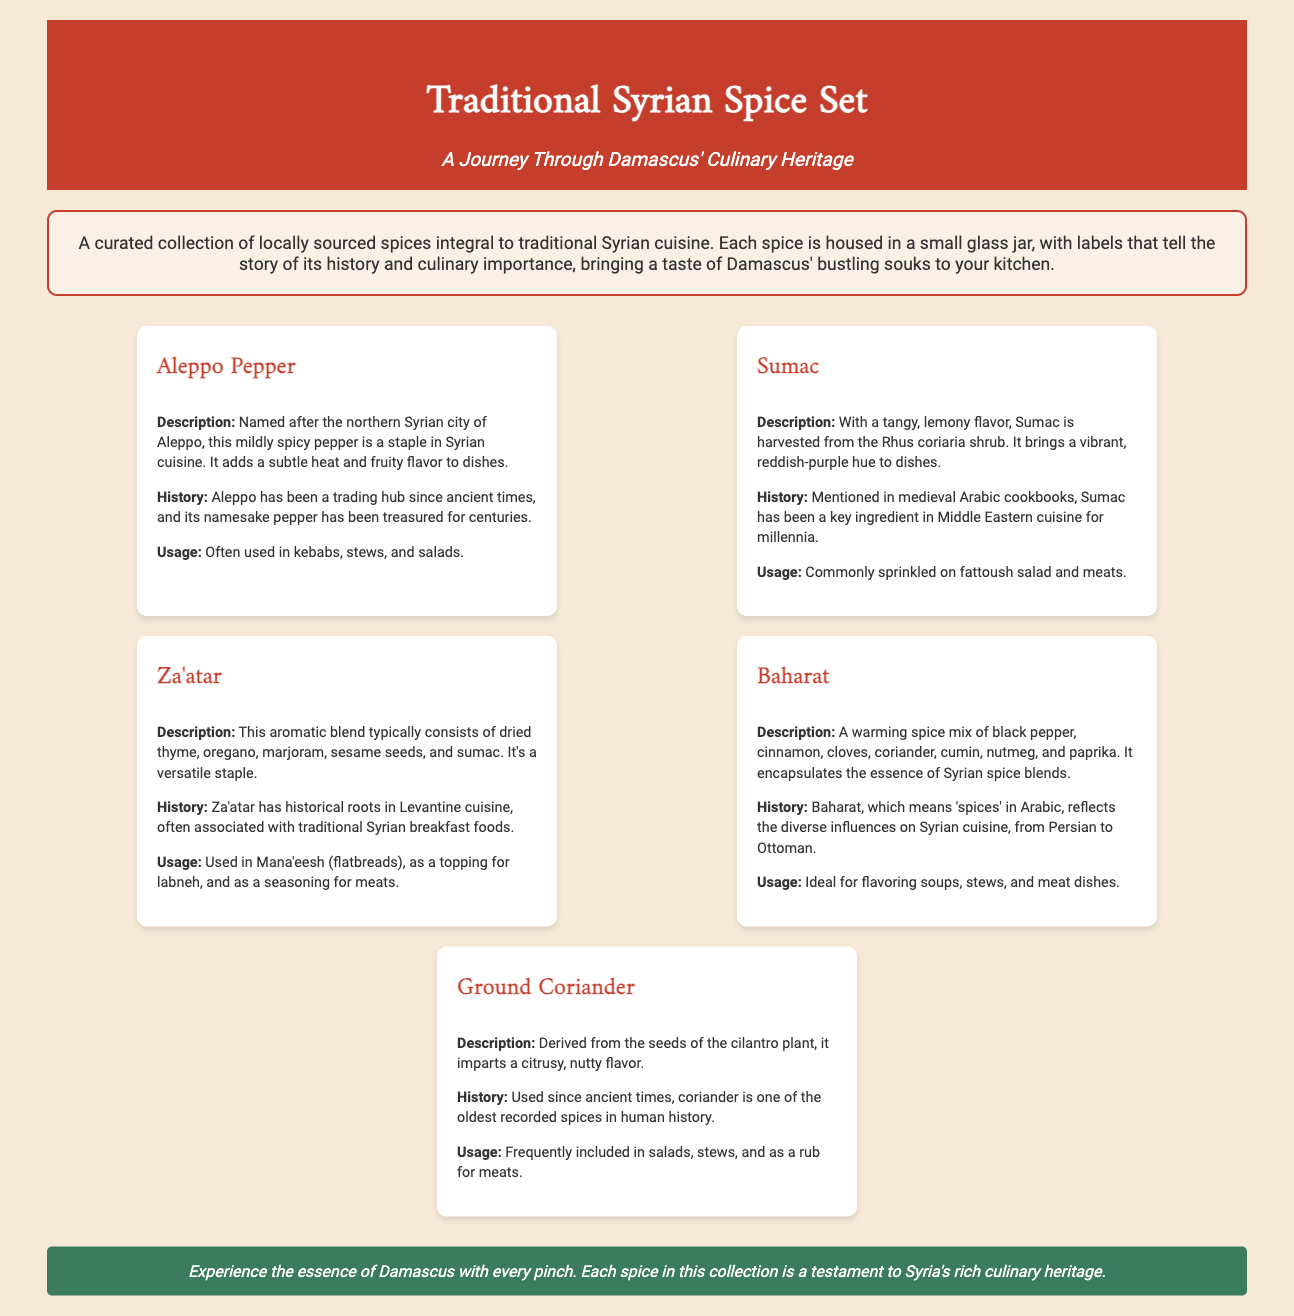What is the title of the product? The title of the product is prominently displayed at the top of the document.
Answer: Traditional Syrian Spice Set How many spices are included in the set? The document lists five different spices, each in its own section.
Answer: Five What spice is made from dried thyme and sesame seeds? The description outlines the components of this spice blend.
Answer: Za'atar Which spice is described as having a tangy, lemony flavor? The document specifically highlights the flavor profile of this spice.
Answer: Sumac What city is Aleppo Pepper named after? The document provides the origin of the name of this spice.
Answer: Aleppo What does "Baharat" mean in Arabic? The document states the meaning of the word in its history section.
Answer: Spices Which spice is commonly used in Mana'eesh? The document mentions a specific usage of this spice in traditional foods.
Answer: Za'atar What color scheme is reflected in the product packaging? The description of the imagery and color scheme references the markets.
Answer: Colors of the souks of Damascus 